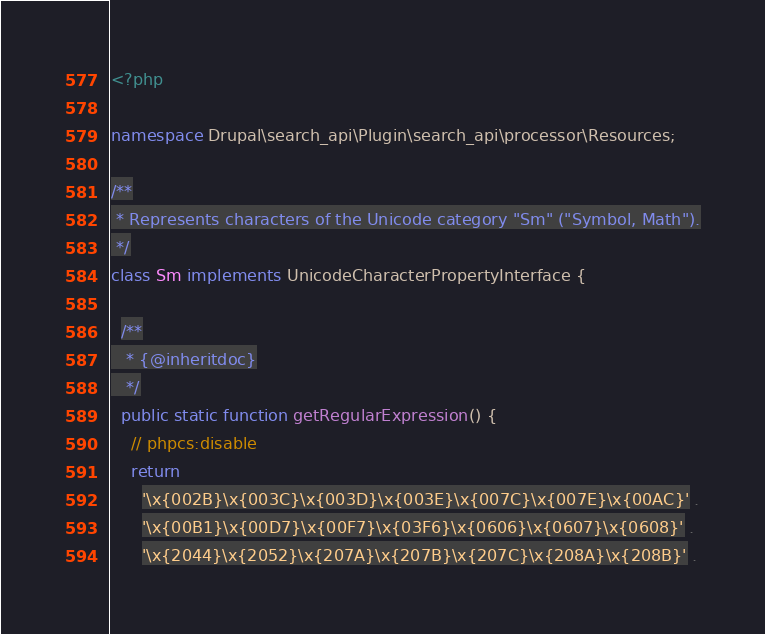Convert code to text. <code><loc_0><loc_0><loc_500><loc_500><_PHP_><?php

namespace Drupal\search_api\Plugin\search_api\processor\Resources;

/**
 * Represents characters of the Unicode category "Sm" ("Symbol, Math").
 */
class Sm implements UnicodeCharacterPropertyInterface {

  /**
   * {@inheritdoc}
   */
  public static function getRegularExpression() {
    // phpcs:disable
    return
      '\x{002B}\x{003C}\x{003D}\x{003E}\x{007C}\x{007E}\x{00AC}' .
      '\x{00B1}\x{00D7}\x{00F7}\x{03F6}\x{0606}\x{0607}\x{0608}' .
      '\x{2044}\x{2052}\x{207A}\x{207B}\x{207C}\x{208A}\x{208B}' .</code> 